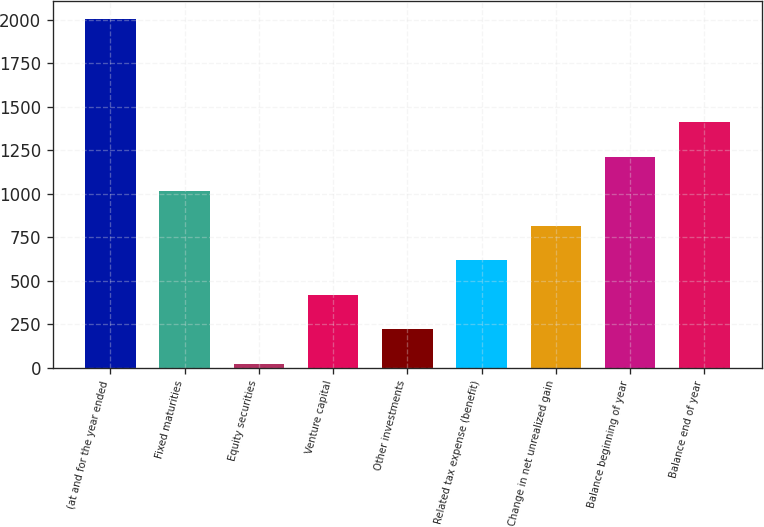Convert chart to OTSL. <chart><loc_0><loc_0><loc_500><loc_500><bar_chart><fcel>(at and for the year ended<fcel>Fixed maturities<fcel>Equity securities<fcel>Venture capital<fcel>Other investments<fcel>Related tax expense (benefit)<fcel>Change in net unrealized gain<fcel>Balance beginning of year<fcel>Balance end of year<nl><fcel>2007<fcel>1014.5<fcel>22<fcel>419<fcel>220.5<fcel>617.5<fcel>816<fcel>1213<fcel>1411.5<nl></chart> 